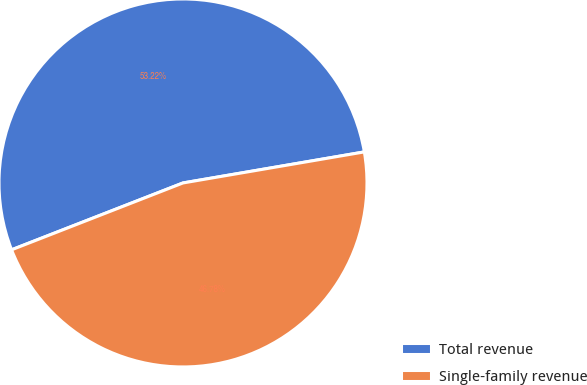Convert chart. <chart><loc_0><loc_0><loc_500><loc_500><pie_chart><fcel>Total revenue<fcel>Single-family revenue<nl><fcel>53.22%<fcel>46.78%<nl></chart> 